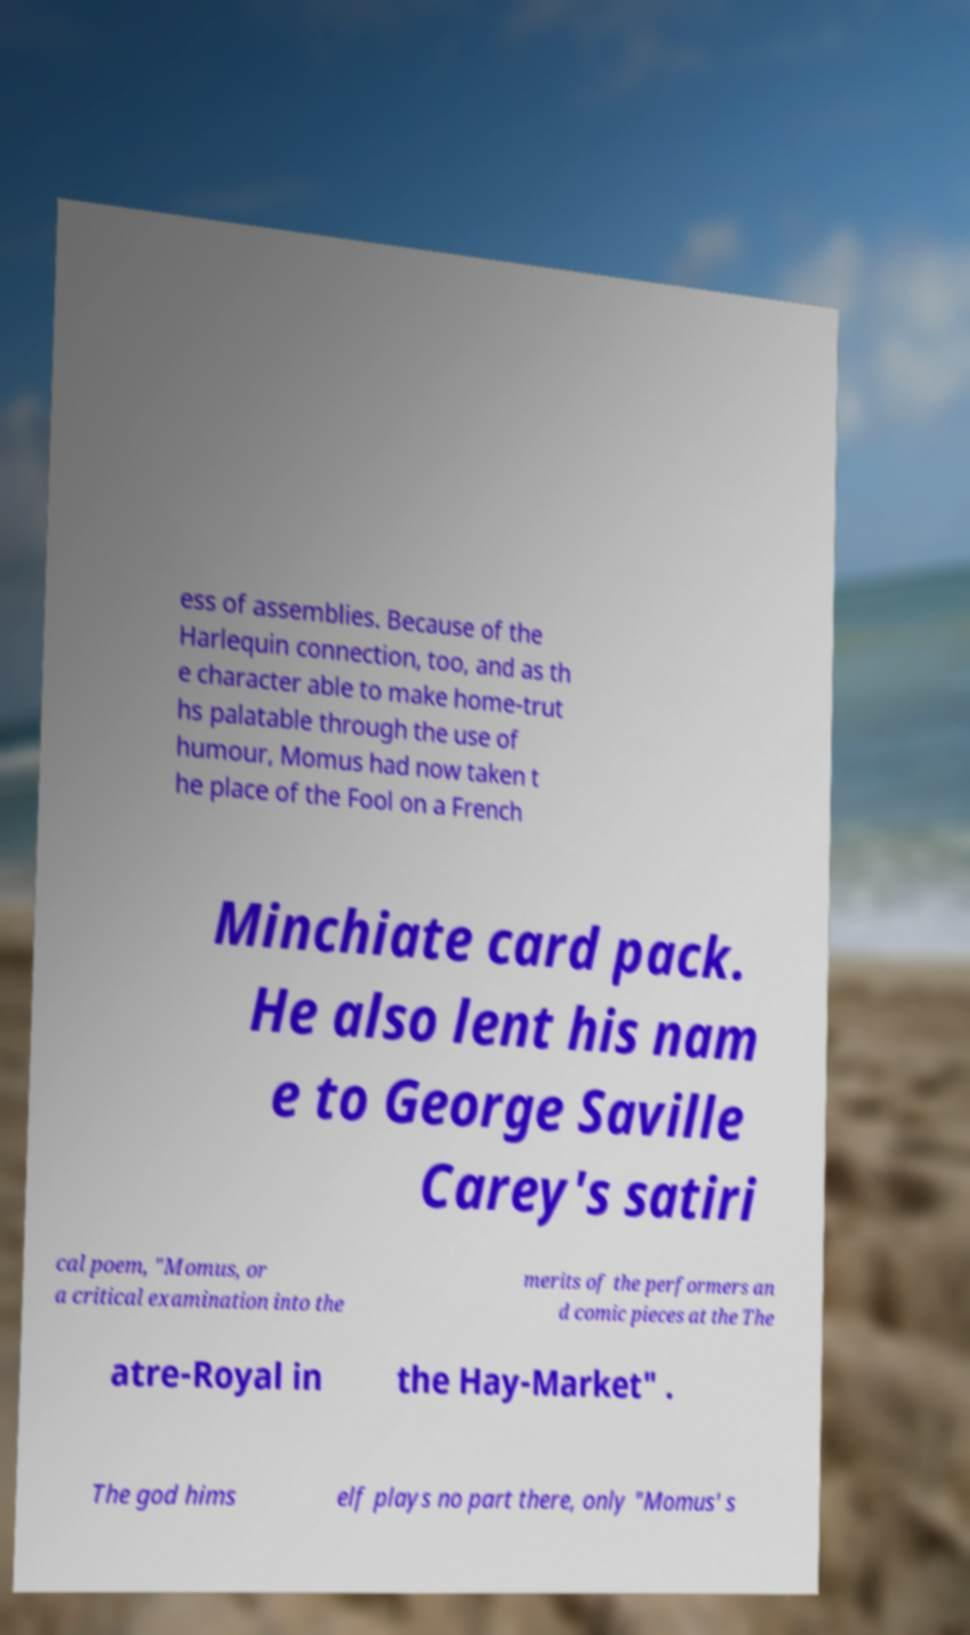Can you accurately transcribe the text from the provided image for me? ess of assemblies. Because of the Harlequin connection, too, and as th e character able to make home-trut hs palatable through the use of humour, Momus had now taken t he place of the Fool on a French Minchiate card pack. He also lent his nam e to George Saville Carey's satiri cal poem, "Momus, or a critical examination into the merits of the performers an d comic pieces at the The atre-Royal in the Hay-Market" . The god hims elf plays no part there, only "Momus' s 